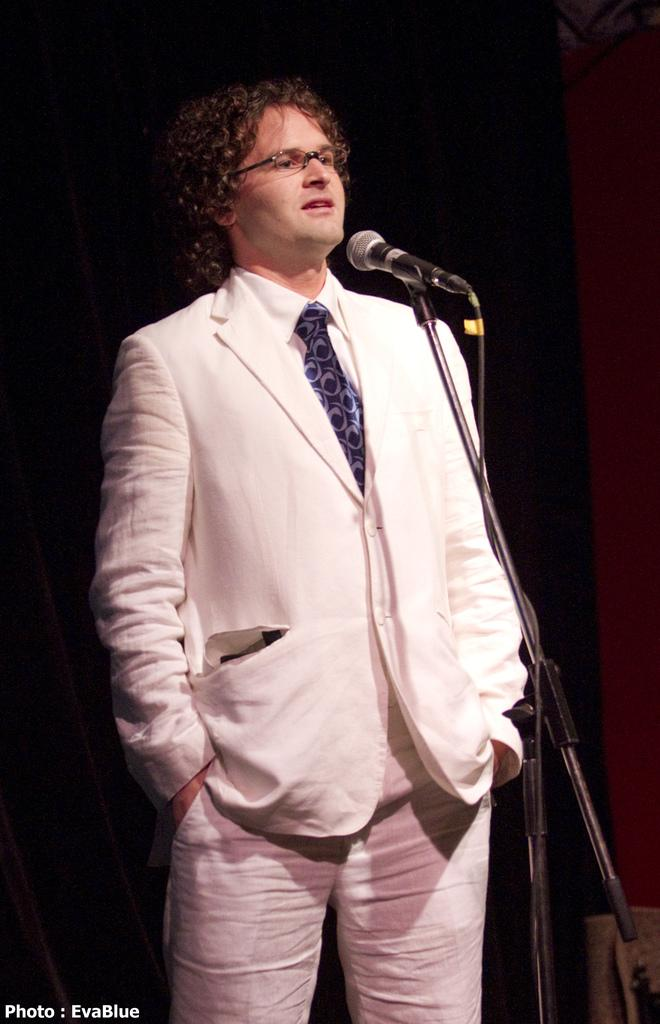What is the main subject of the image? There is a person in the image. What is the person wearing on their upper body? The person is wearing a cream blazer, a white shirt, and a blue tie. What object is in front of the person? There is a microphone in front of the person. What type of sponge is being used by the person in the image? There is no sponge present in the image; the person is wearing a cream blazer, a white shirt, and a blue tie, and there is a microphone in front of them. 